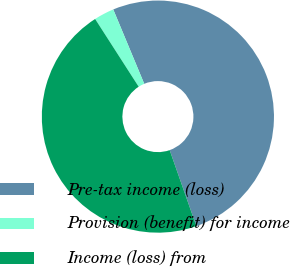Convert chart. <chart><loc_0><loc_0><loc_500><loc_500><pie_chart><fcel>Pre-tax income (loss)<fcel>Provision (benefit) for income<fcel>Income (loss) from<nl><fcel>50.91%<fcel>2.81%<fcel>46.28%<nl></chart> 